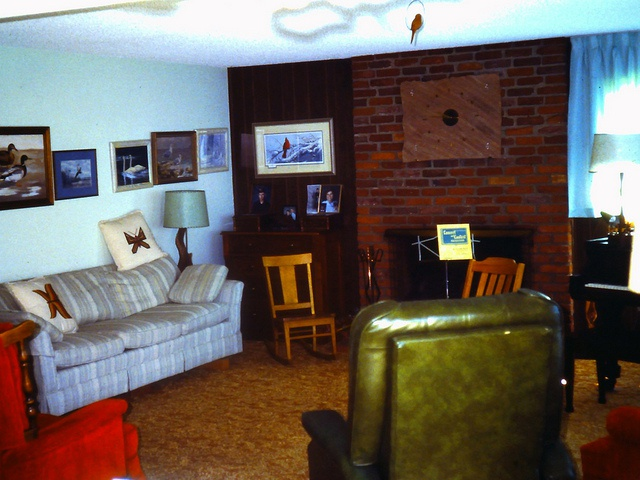Describe the objects in this image and their specific colors. I can see chair in white, black, and olive tones, couch in white, black, and olive tones, couch in white, darkgray, and gray tones, chair in white, maroon, black, and brown tones, and clock in white, maroon, black, and brown tones in this image. 